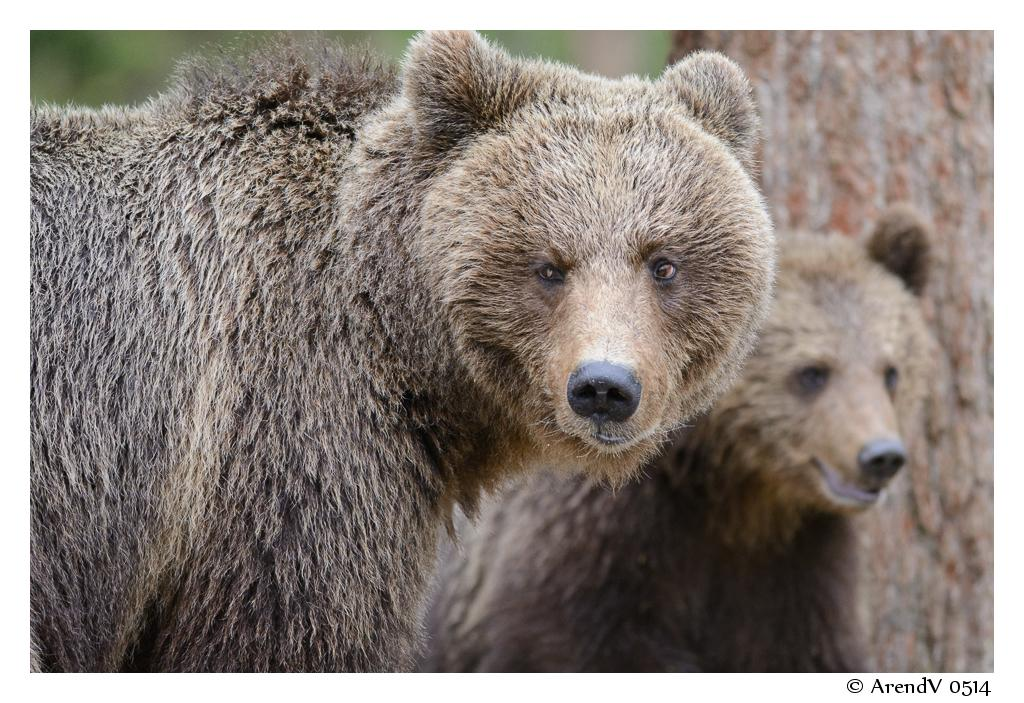How many bears are present in the image? There are two bears in the image. Can you describe the quality of the image? The image is slightly blurry in the background. Is there any additional information or branding present in the image? Yes, there is a watermark in the bottom right corner of the image. What type of leaf is being used to wash the bears in the image? There is no leaf or washing activity present in the image; it features two bears. 